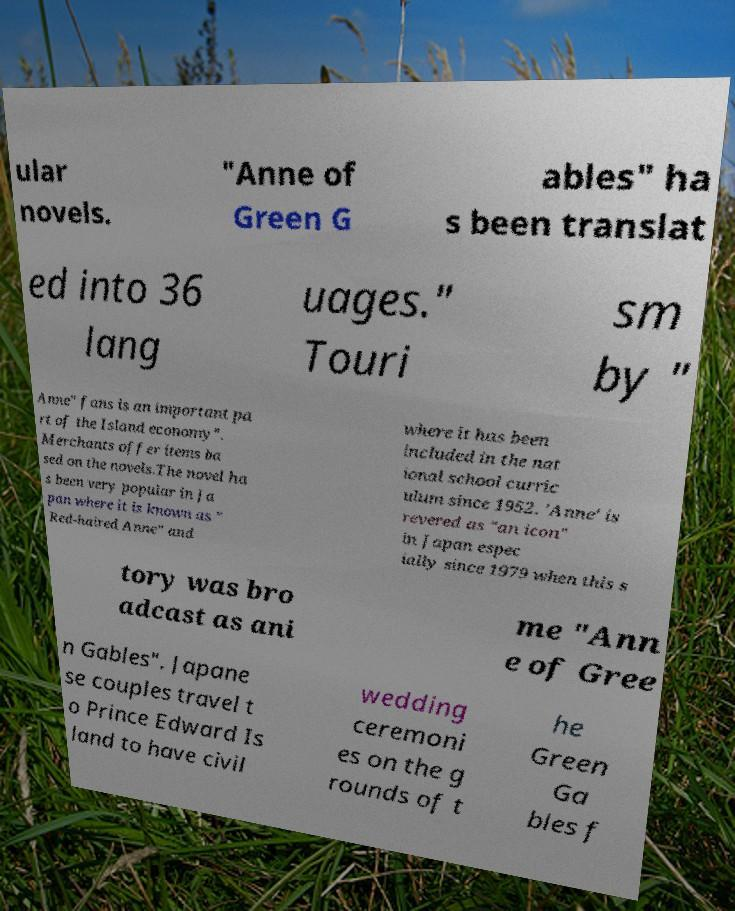Can you read and provide the text displayed in the image?This photo seems to have some interesting text. Can you extract and type it out for me? ular novels. "Anne of Green G ables" ha s been translat ed into 36 lang uages." Touri sm by " Anne" fans is an important pa rt of the Island economy". Merchants offer items ba sed on the novels.The novel ha s been very popular in Ja pan where it is known as " Red-haired Anne" and where it has been included in the nat ional school curric ulum since 1952. 'Anne' is revered as "an icon" in Japan espec ially since 1979 when this s tory was bro adcast as ani me "Ann e of Gree n Gables". Japane se couples travel t o Prince Edward Is land to have civil wedding ceremoni es on the g rounds of t he Green Ga bles f 